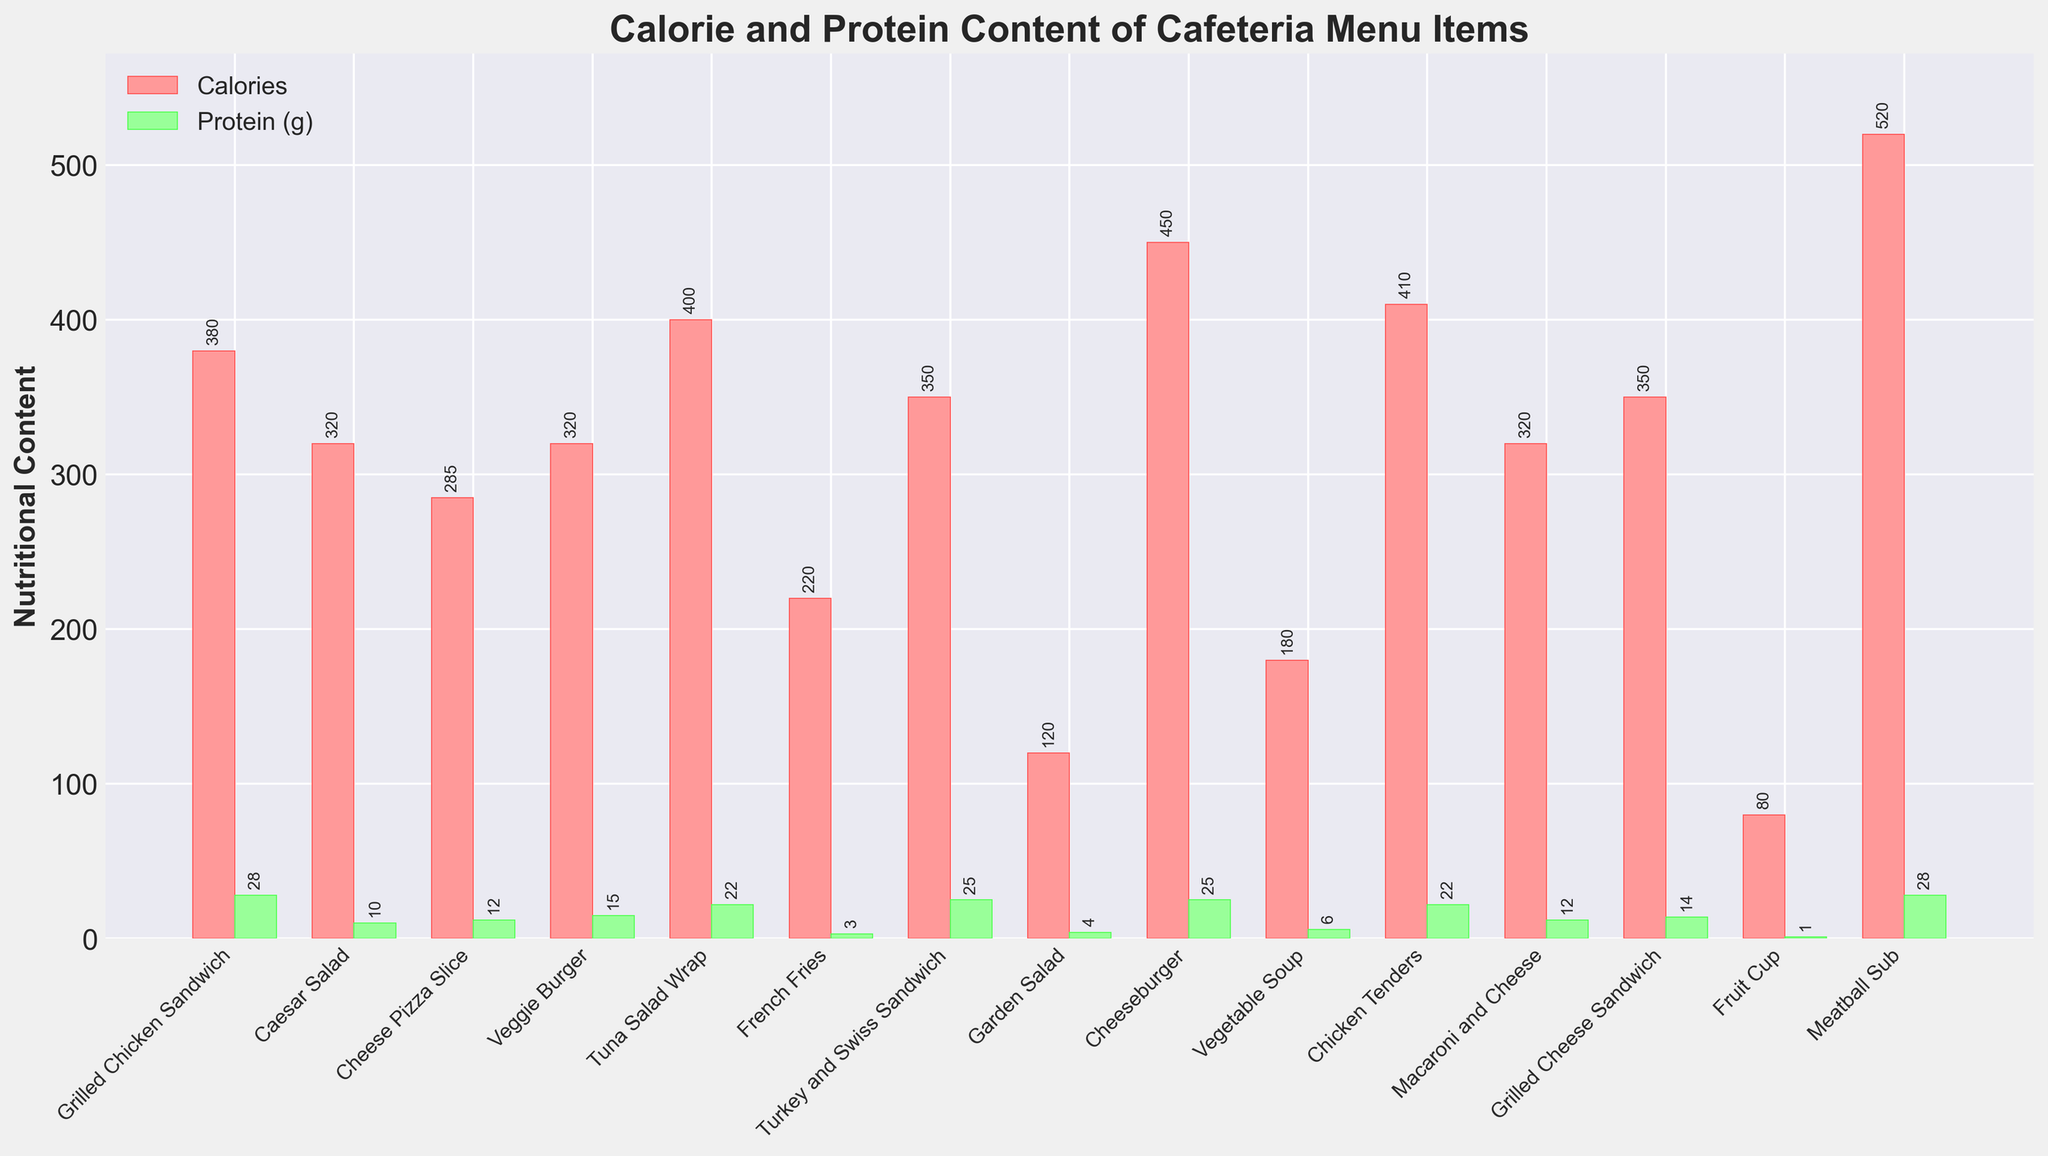What's the menu item with the highest calorie content? Look at the bar height representing calories for each menu item and compare them. The highest bar represents the item with the highest calorie content.
Answer: Meatball Sub Which item has more protein, the Grilled Chicken Sandwich or the Veggie Burger? Compare the height of the green bars (representing protein) for Grilled Chicken Sandwich and Veggie Burger. The taller bar indicates more protein.
Answer: Grilled Chicken Sandwich What are the total calories for the Caesar Salad and the Tuna Salad Wrap combined? Add the calorie values for Caesar Salad (320) and Tuna Salad Wrap (400).
Answer: 320 + 400 = 720 Which item has the least protein content? Identify the smallest green bar (representing protein content).
Answer: Fruit Cup Does the Chicken Tenders have more calories or more protein? Compare the height of the red bar (calories) with the height of the green bar (protein) for Chicken Tenders.
Answer: More calories What's the difference in calorie content between the Cheeseburger and the French Fries? Subtract the calorie content of French Fries (220) from the calorie content of Cheeseburger (450).
Answer: 450 - 220 = 230 Which item has approximately equal calories and protein content? Look for items where the heights of the red bar and the green bar are roughly equal.
Answer: None (all pairs show a noticeable difference) How many items have calorie contents greater than 400? Count the number of items where the height of the red bar is above the 400 mark.
Answer: 4 items (Tuna Salad Wrap, Chicken Tenders, Meatball Sub, Cheeseburger) Which item has more calories, the Macaroni and Cheese or the Turkey and Swiss Sandwich? Compare the height of the red bars for Macaroni and Cheese and Turkey and Swiss Sandwich. The taller bar indicates more calories.
Answer: Turkey and Swiss Sandwich What is the average protein content of all menu items? Sum up all protein content values (1+4+6+10+12+12+14+15+22+22+25+25+28+28) and divide by the number of items (14).
Answer: Sum = 242, Average = 242/14 = 17.3 